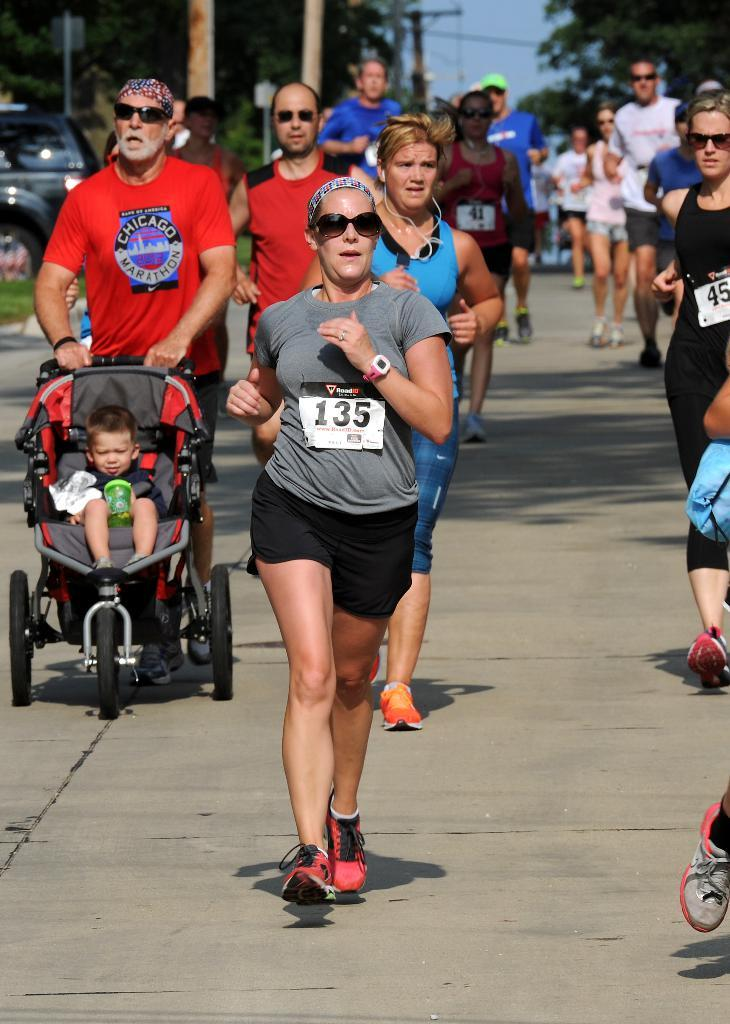What are the people in the image doing? The people in the image are running on the road. Can you describe the man in the image? The man is holding a trolley with a baby. What can be seen in the background of the image? Trees and electric poles are visible in the image. What else is present on the road in the image? There is at least one car on the road in the image. What type of drug is the man holding in the image? There is no drug present in the image; the man is holding a trolley with a baby. Can you tell me how many balloons are tied to the trees in the image? There are no balloons visible in the image; only trees and electric poles are present in the background. 